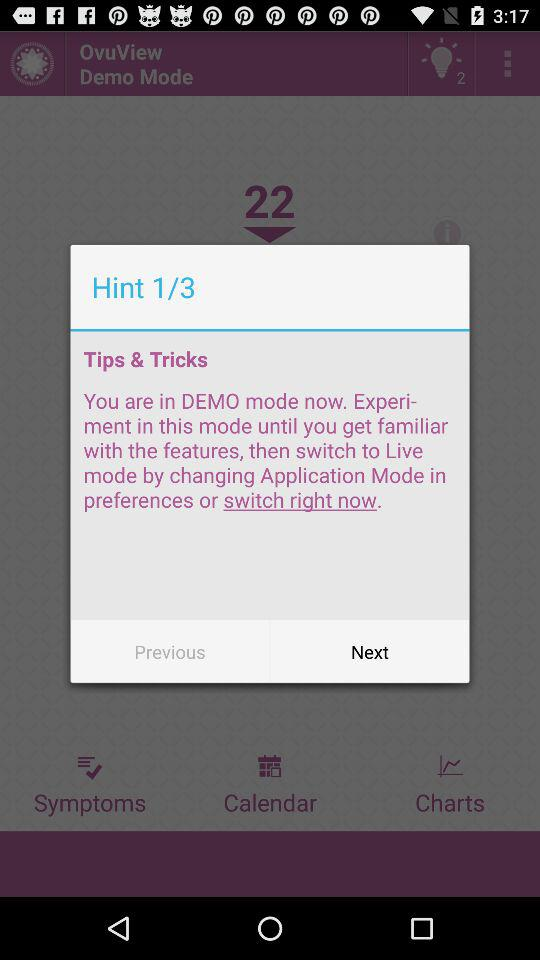What is the name of the application? The name of the application is "OvuView". 